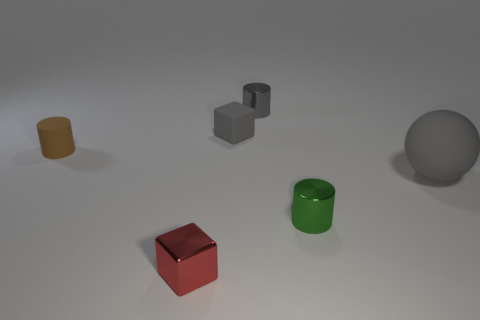Can you describe the arrangement of colors in the image? Certainly! Arranged from left to right, we see earth-toned and primary colors starting with a muted yellow, followed by a vivid red, a neutral gray, an organic green, and ending with a cool gray sphere. How do the colors influence the visual balance of the composition? The placement of colors creates a visual rhythm that guides the eye across the picture. The bright red cube in the foreground acts as a strong focal point, while the subdued yellow and green add balance, and the gray objects provide neutral resting spots for the viewer's gaze. 